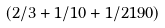<formula> <loc_0><loc_0><loc_500><loc_500>( 2 / 3 + 1 / 1 0 + 1 / 2 1 9 0 )</formula> 